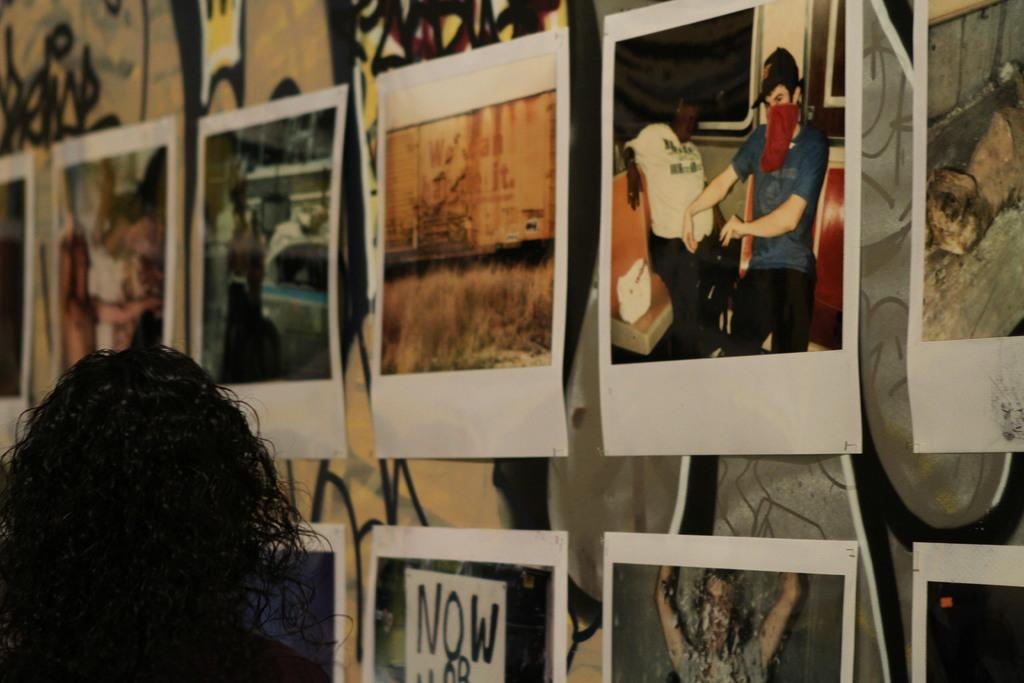What is on the wall in the image? There are posters on the wall in the image. Can you describe the person's head visible on the left side of the image? The head of a person is visible on the left side of the image. Is there any smoke coming from the person's head in the image? No, there is no smoke coming from the person's head in the image. What page is the person reading in the image? There is no page visible in the image, as only the person's head is shown. 